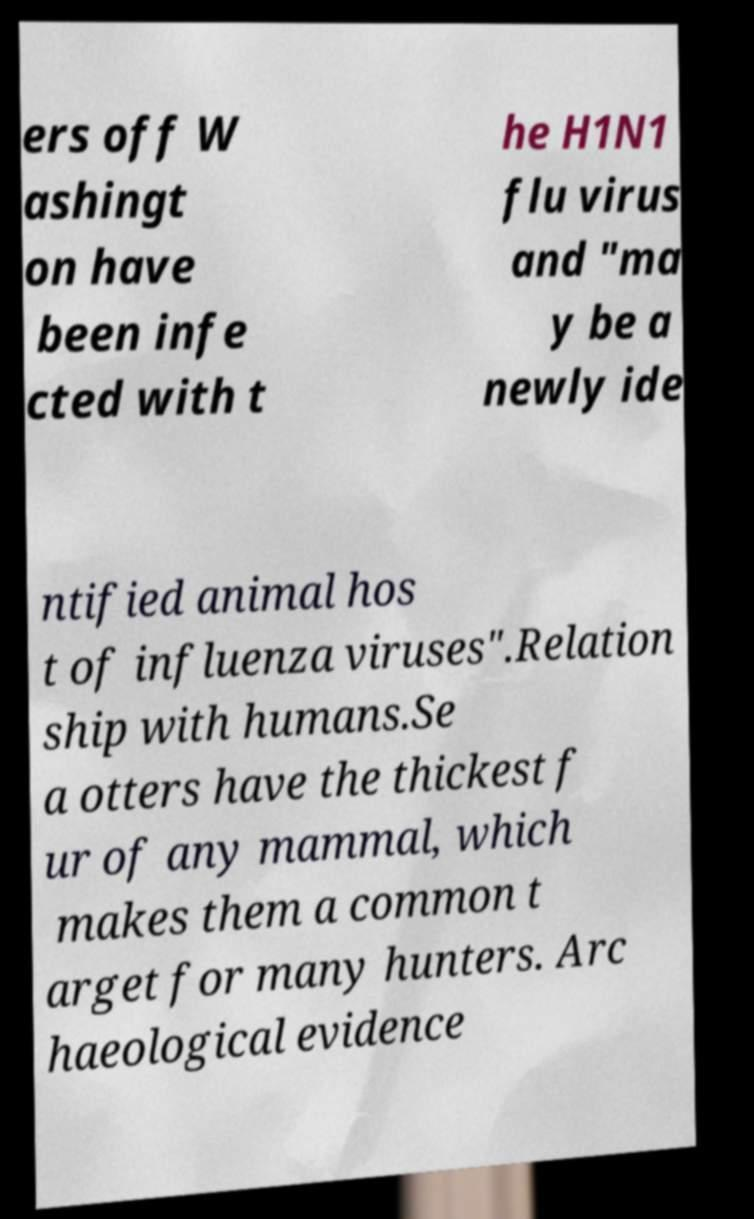What messages or text are displayed in this image? I need them in a readable, typed format. ers off W ashingt on have been infe cted with t he H1N1 flu virus and "ma y be a newly ide ntified animal hos t of influenza viruses".Relation ship with humans.Se a otters have the thickest f ur of any mammal, which makes them a common t arget for many hunters. Arc haeological evidence 